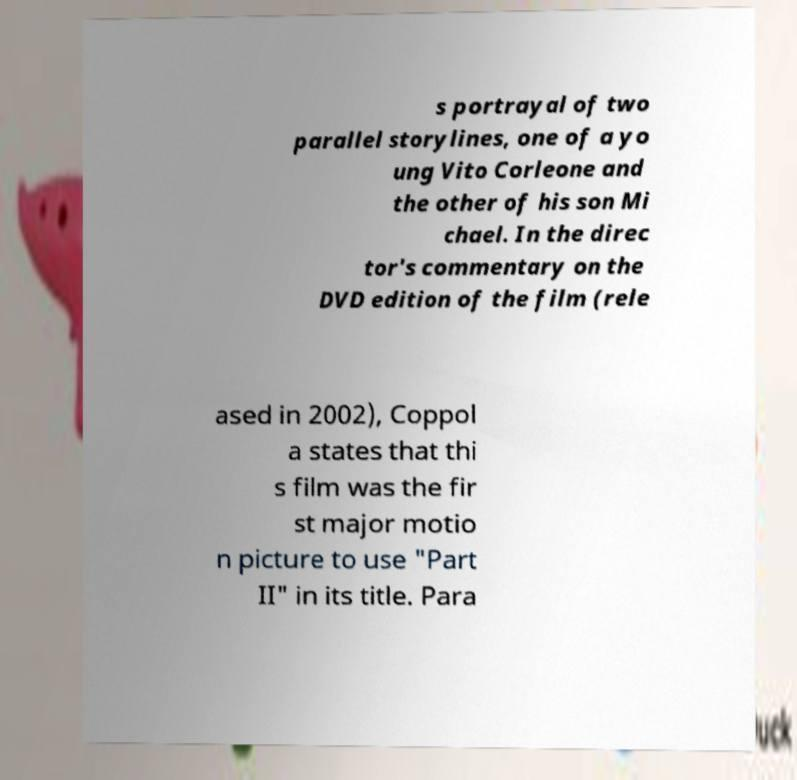What messages or text are displayed in this image? I need them in a readable, typed format. s portrayal of two parallel storylines, one of a yo ung Vito Corleone and the other of his son Mi chael. In the direc tor's commentary on the DVD edition of the film (rele ased in 2002), Coppol a states that thi s film was the fir st major motio n picture to use "Part II" in its title. Para 